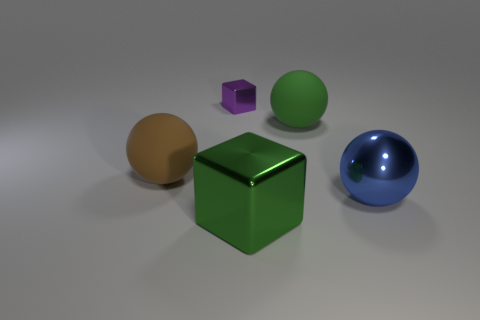Is the number of matte objects that are on the right side of the large blue metal object the same as the number of large brown balls?
Give a very brief answer. No. Is the blue ball the same size as the purple metallic block?
Ensure brevity in your answer.  No. There is a big ball that is both to the left of the large blue shiny thing and in front of the large green matte ball; what material is it?
Offer a very short reply. Rubber. How many other tiny purple metal objects are the same shape as the tiny purple shiny thing?
Ensure brevity in your answer.  0. There is a green object to the left of the big green ball; what is it made of?
Make the answer very short. Metal. Is the number of big metallic blocks that are left of the tiny purple object less than the number of large green shiny things?
Your answer should be very brief. Yes. Is the small purple object the same shape as the green shiny thing?
Make the answer very short. Yes. Is there anything else that is the same shape as the purple metallic thing?
Ensure brevity in your answer.  Yes. Are there any big metal cubes?
Your answer should be compact. Yes. There is a brown matte object; is its shape the same as the green thing behind the big green metal block?
Make the answer very short. Yes. 